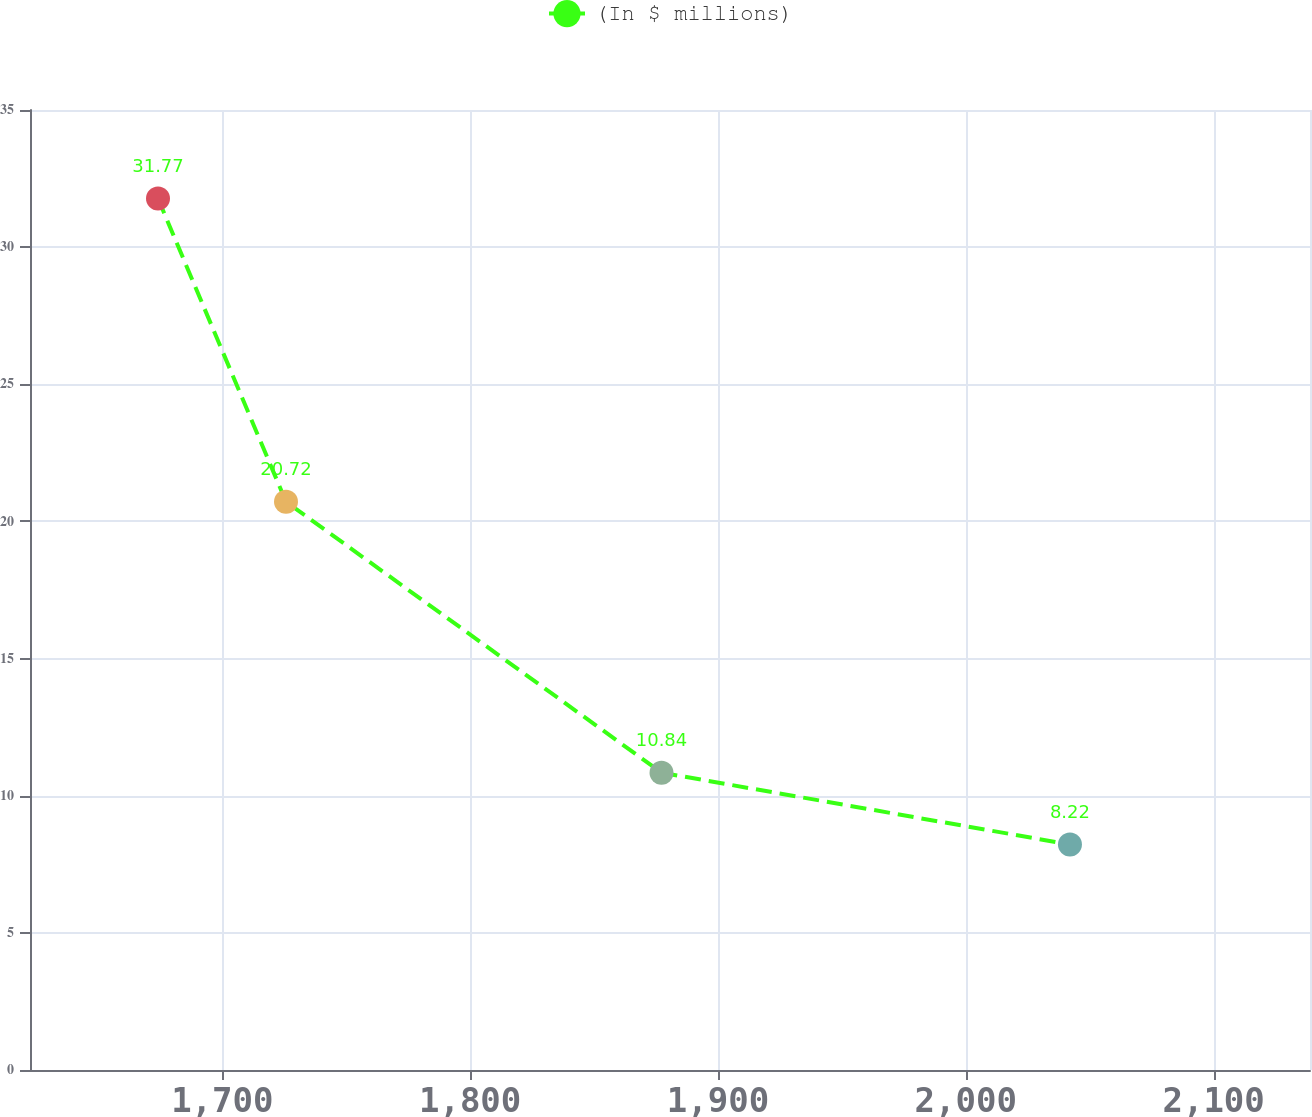<chart> <loc_0><loc_0><loc_500><loc_500><line_chart><ecel><fcel>(In $ millions)<nl><fcel>1674.05<fcel>31.77<nl><fcel>1725.7<fcel>20.72<nl><fcel>1877.22<fcel>10.84<nl><fcel>2042.03<fcel>8.22<nl><fcel>2190.54<fcel>5.6<nl></chart> 